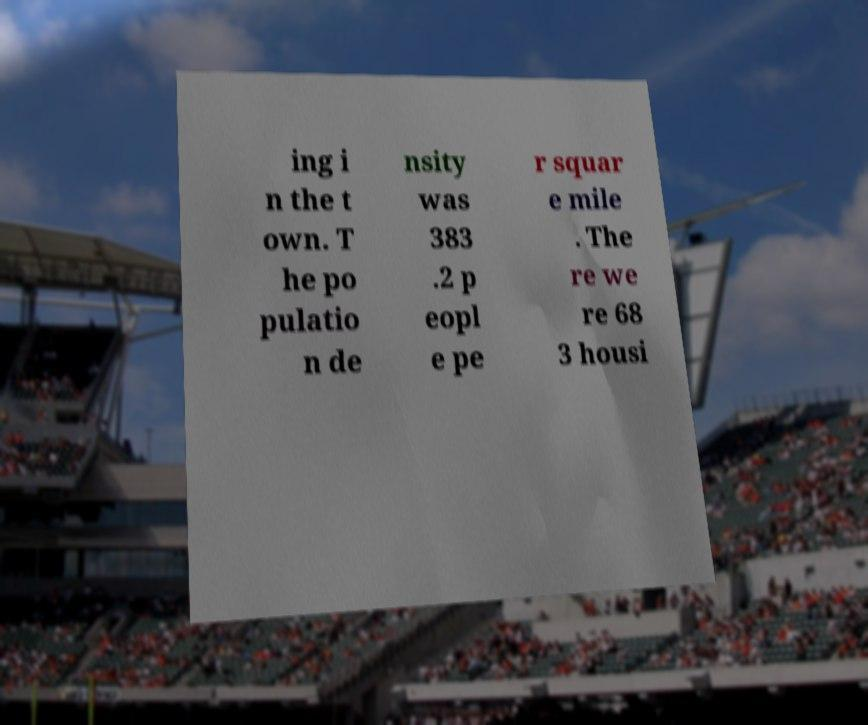For documentation purposes, I need the text within this image transcribed. Could you provide that? ing i n the t own. T he po pulatio n de nsity was 383 .2 p eopl e pe r squar e mile . The re we re 68 3 housi 